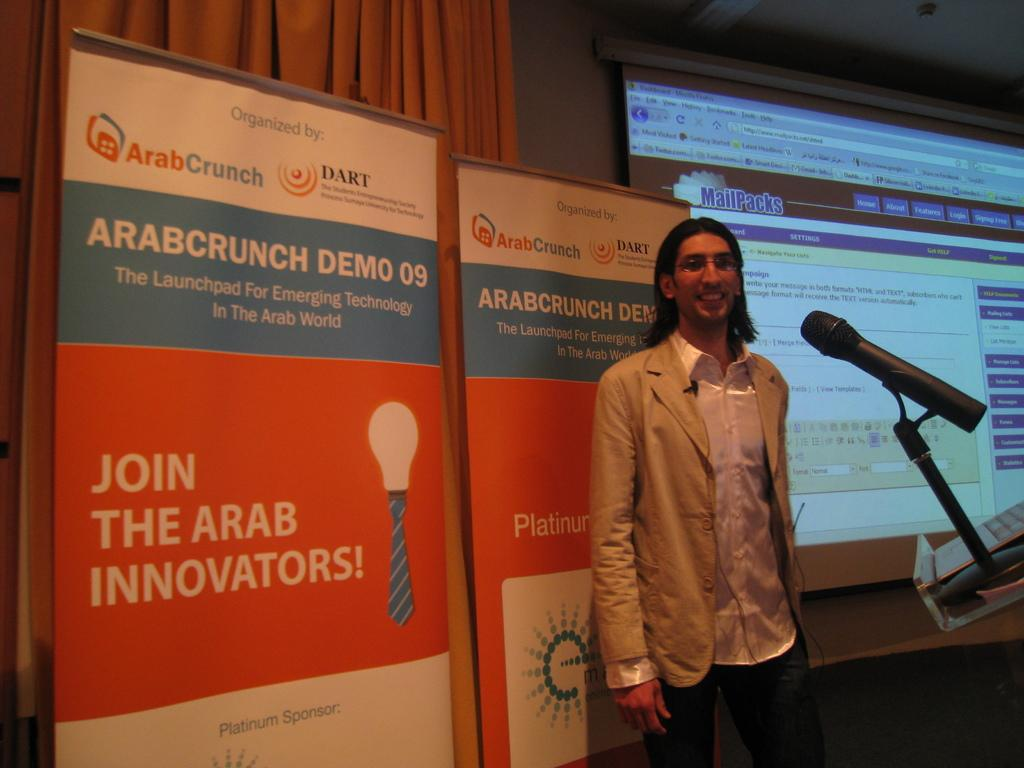What is the main subject of the image? There is a person standing in the image. What object is visible near the person? There is a microphone (mic) in the image. What type of decorations are present in the image? There are banners in the image. What type of covering is present in the image? There is a curtain in the image. What type of structure is visible in the image? There is a wall in the image. What type of display device is visible in the image? There is a projector-screen in the image. What type of rice is being served in the image? There is no rice present in the image. What type of soap is being used to clean the projector-screen in the image? There is no soap or cleaning activity depicted in the image. 